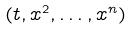<formula> <loc_0><loc_0><loc_500><loc_500>( t , x ^ { 2 } , \dots , x ^ { n } )</formula> 